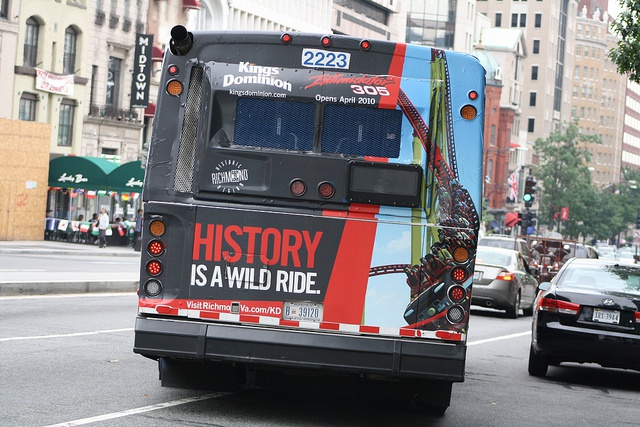Describe the objects in this image and their specific colors. I can see bus in lightgray, black, gray, and darkblue tones, car in lightgray, black, darkgray, and gray tones, car in lightgray, white, gray, black, and darkgray tones, car in lightgray, darkgray, and gray tones, and people in lightgray, lavender, gray, darkgray, and black tones in this image. 